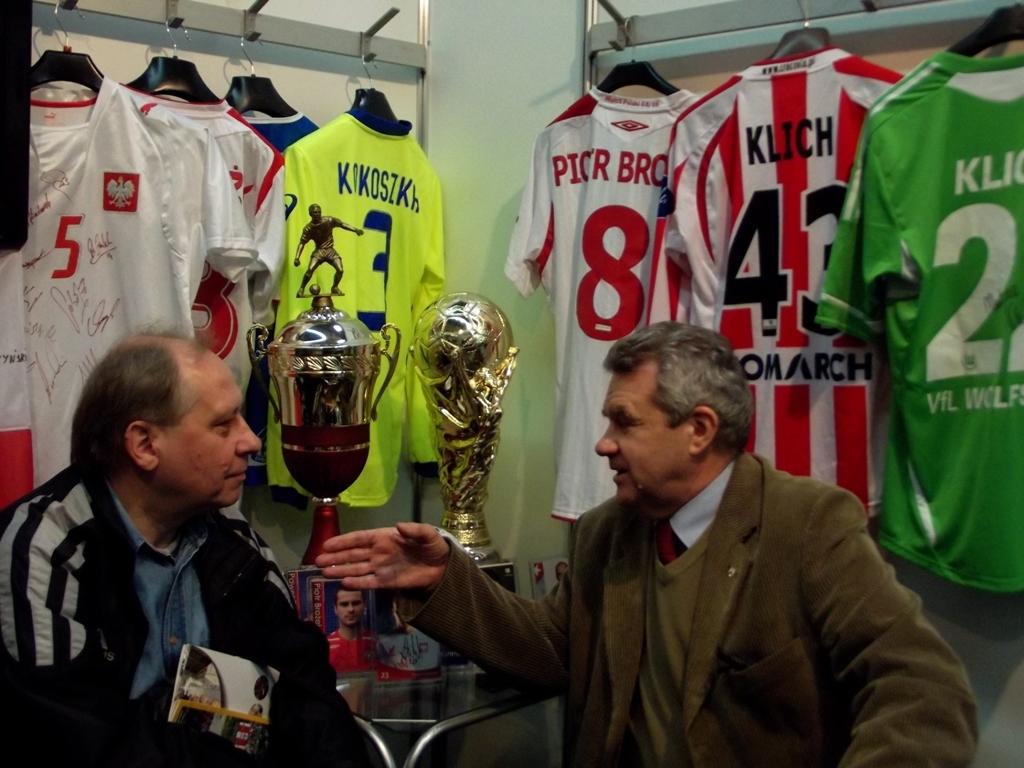What is the name printed on the red and white striped jersey?
Your response must be concise. Klich. 